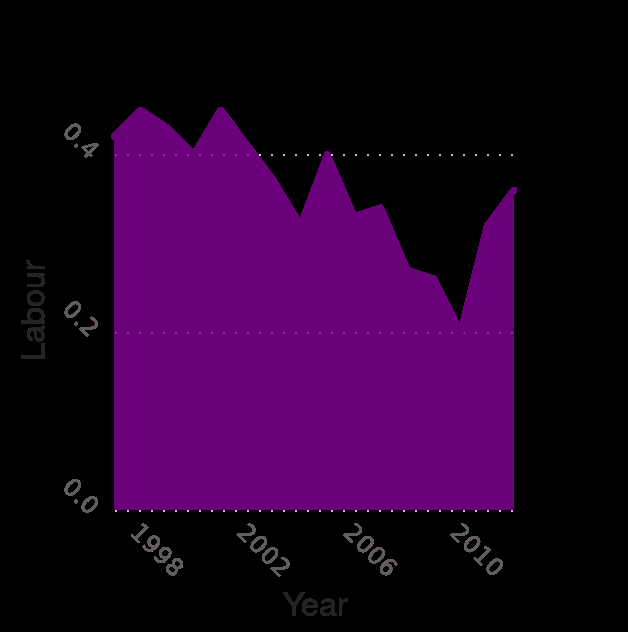<image>
please summary the statistics and relations of the chart There have been sharp peaks and troughs here with a record low in 2010 before they started to climb back up. What is plotted on the x-axis of the area plot? The x-axis of the area plot represents the years from 1998 to 2010 on a linear scale. When did the sharp peaks and troughs begin to occur?  The sharp peaks and troughs began to occur before 2010. 